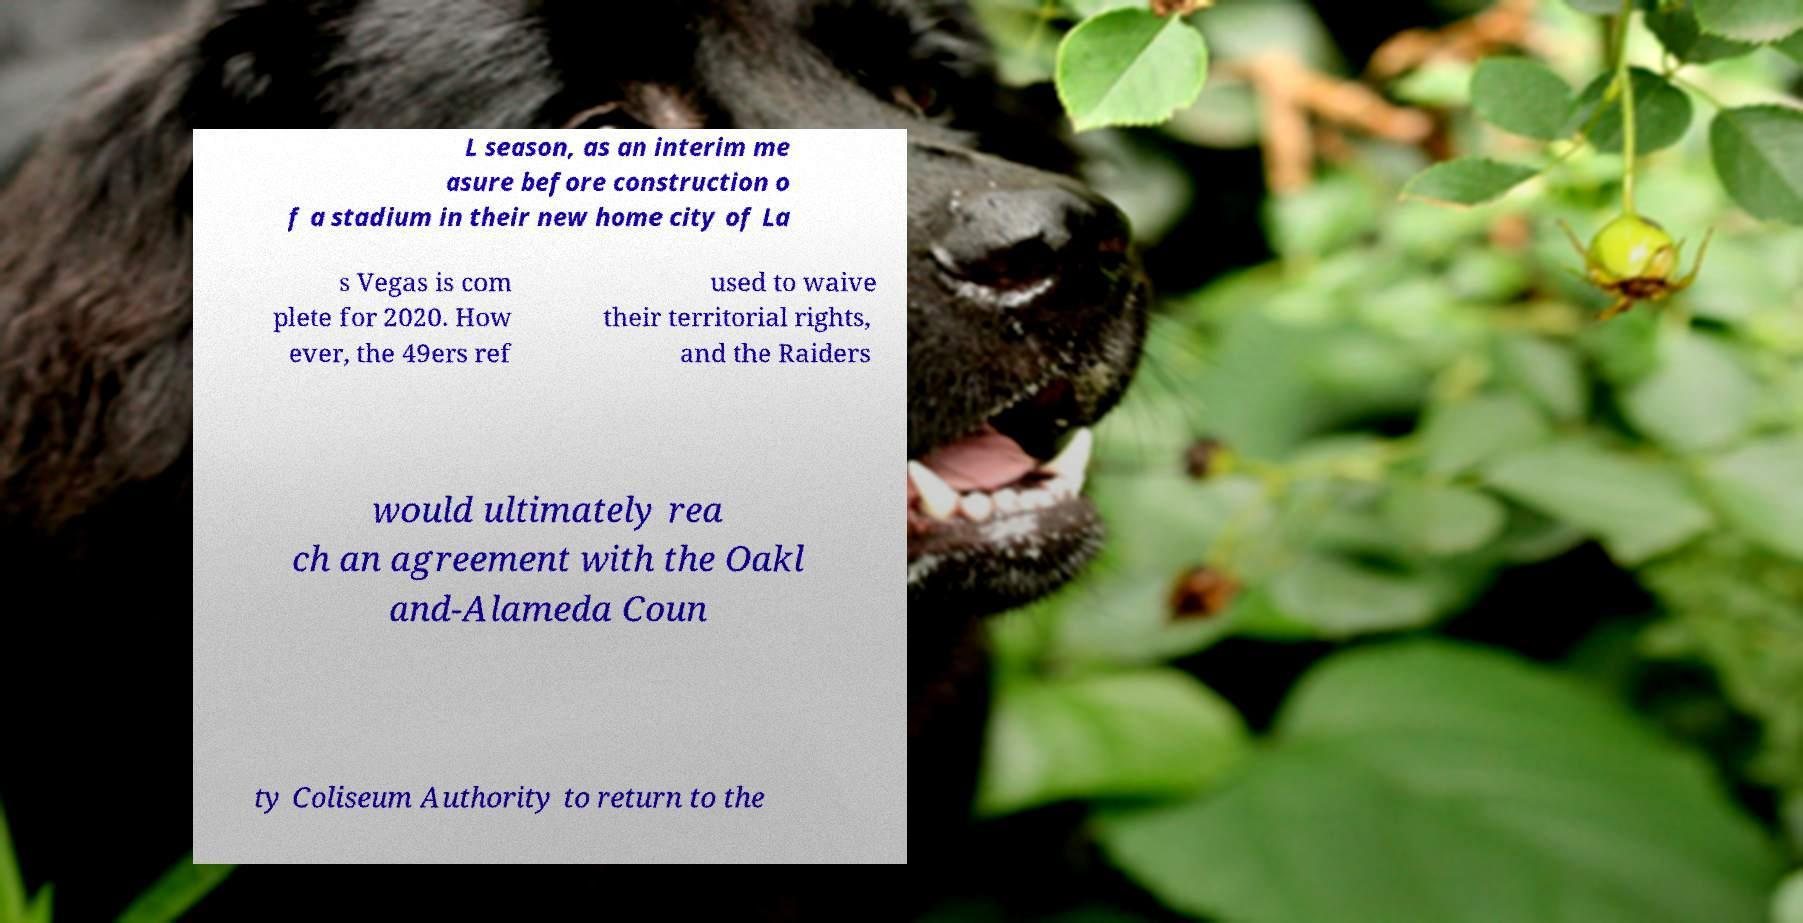Please identify and transcribe the text found in this image. L season, as an interim me asure before construction o f a stadium in their new home city of La s Vegas is com plete for 2020. How ever, the 49ers ref used to waive their territorial rights, and the Raiders would ultimately rea ch an agreement with the Oakl and-Alameda Coun ty Coliseum Authority to return to the 